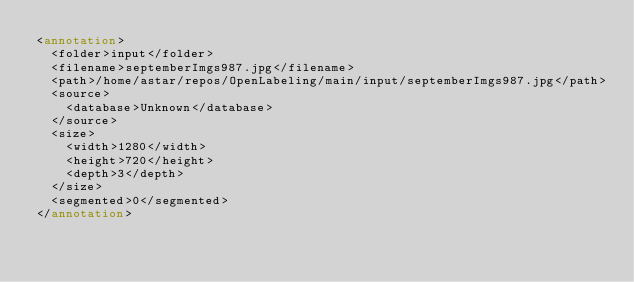Convert code to text. <code><loc_0><loc_0><loc_500><loc_500><_XML_><annotation>
  <folder>input</folder>
  <filename>septemberImgs987.jpg</filename>
  <path>/home/astar/repos/OpenLabeling/main/input/septemberImgs987.jpg</path>
  <source>
    <database>Unknown</database>
  </source>
  <size>
    <width>1280</width>
    <height>720</height>
    <depth>3</depth>
  </size>
  <segmented>0</segmented>
</annotation>
</code> 